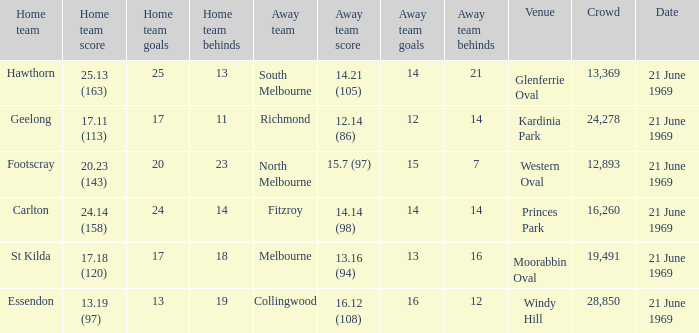Could you parse the entire table? {'header': ['Home team', 'Home team score', 'Home team goals', 'Home team behinds', 'Away team', 'Away team score', 'Away team goals', 'Away team behinds', 'Venue', 'Crowd', 'Date'], 'rows': [['Hawthorn', '25.13 (163)', '25', '13', 'South Melbourne', '14.21 (105)', '14', '21', 'Glenferrie Oval', '13,369', '21 June 1969'], ['Geelong', '17.11 (113)', '17', '11', 'Richmond', '12.14 (86)', '12', '14', 'Kardinia Park', '24,278', '21 June 1969'], ['Footscray', '20.23 (143)', '20', '23', 'North Melbourne', '15.7 (97)', '15', '7', 'Western Oval', '12,893', '21 June 1969'], ['Carlton', '24.14 (158)', '24', '14', 'Fitzroy', '14.14 (98)', '14', '14', 'Princes Park', '16,260', '21 June 1969'], ['St Kilda', '17.18 (120)', '17', '18', 'Melbourne', '13.16 (94)', '13', '16', 'Moorabbin Oval', '19,491', '21 June 1969'], ['Essendon', '13.19 (97)', '13', '19', 'Collingwood', '16.12 (108)', '16', '12', 'Windy Hill', '28,850', '21 June 1969']]} When was there a game at Kardinia Park? 21 June 1969. 